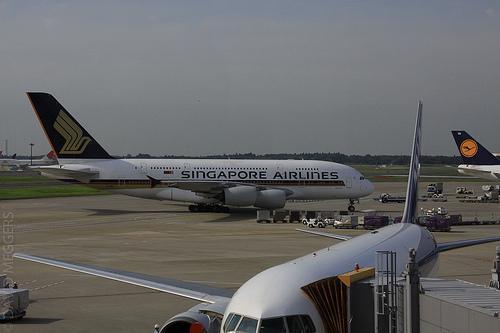How many planes in the picture are completely at the gate and boarding or deplaning?
Give a very brief answer. 1. 